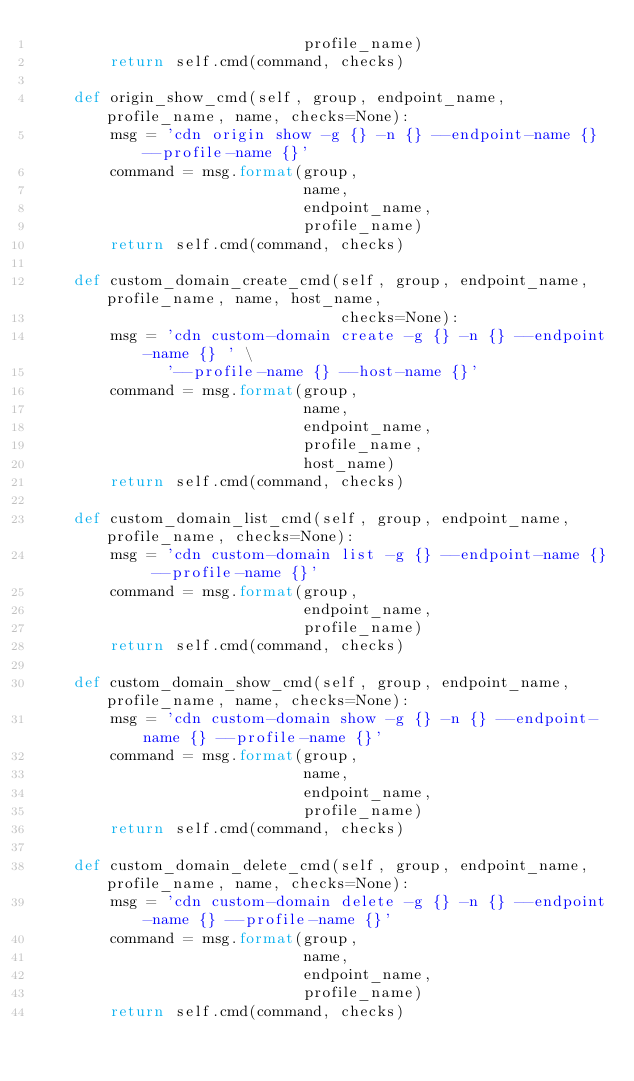Convert code to text. <code><loc_0><loc_0><loc_500><loc_500><_Python_>                             profile_name)
        return self.cmd(command, checks)

    def origin_show_cmd(self, group, endpoint_name, profile_name, name, checks=None):
        msg = 'cdn origin show -g {} -n {} --endpoint-name {} --profile-name {}'
        command = msg.format(group,
                             name,
                             endpoint_name,
                             profile_name)
        return self.cmd(command, checks)

    def custom_domain_create_cmd(self, group, endpoint_name, profile_name, name, host_name,
                                 checks=None):
        msg = 'cdn custom-domain create -g {} -n {} --endpoint-name {} ' \
              '--profile-name {} --host-name {}'
        command = msg.format(group,
                             name,
                             endpoint_name,
                             profile_name,
                             host_name)
        return self.cmd(command, checks)

    def custom_domain_list_cmd(self, group, endpoint_name, profile_name, checks=None):
        msg = 'cdn custom-domain list -g {} --endpoint-name {} --profile-name {}'
        command = msg.format(group,
                             endpoint_name,
                             profile_name)
        return self.cmd(command, checks)

    def custom_domain_show_cmd(self, group, endpoint_name, profile_name, name, checks=None):
        msg = 'cdn custom-domain show -g {} -n {} --endpoint-name {} --profile-name {}'
        command = msg.format(group,
                             name,
                             endpoint_name,
                             profile_name)
        return self.cmd(command, checks)

    def custom_domain_delete_cmd(self, group, endpoint_name, profile_name, name, checks=None):
        msg = 'cdn custom-domain delete -g {} -n {} --endpoint-name {} --profile-name {}'
        command = msg.format(group,
                             name,
                             endpoint_name,
                             profile_name)
        return self.cmd(command, checks)
</code> 